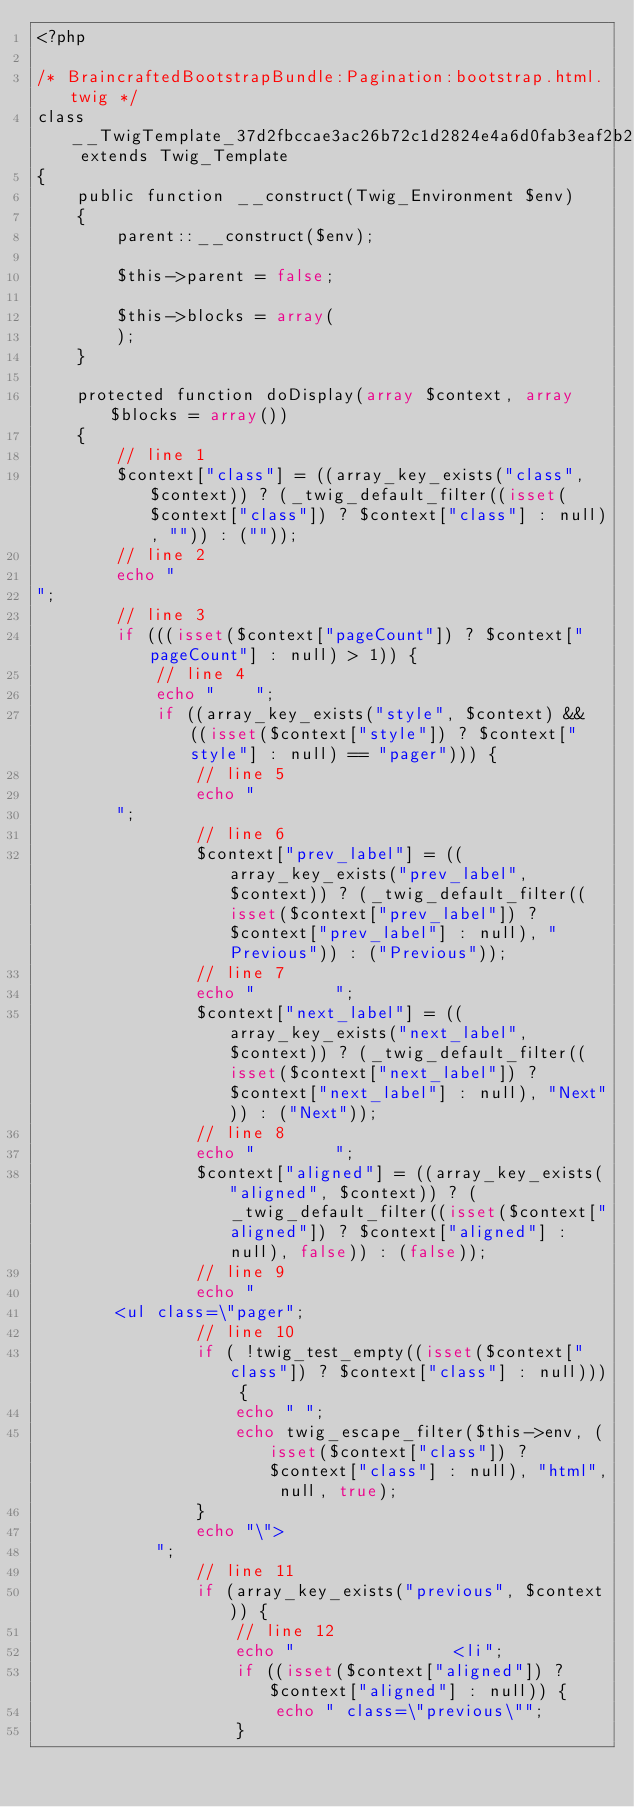<code> <loc_0><loc_0><loc_500><loc_500><_PHP_><?php

/* BraincraftedBootstrapBundle:Pagination:bootstrap.html.twig */
class __TwigTemplate_37d2fbccae3ac26b72c1d2824e4a6d0fab3eaf2b2bd7ce29ca5ebdf883d66af6 extends Twig_Template
{
    public function __construct(Twig_Environment $env)
    {
        parent::__construct($env);

        $this->parent = false;

        $this->blocks = array(
        );
    }

    protected function doDisplay(array $context, array $blocks = array())
    {
        // line 1
        $context["class"] = ((array_key_exists("class", $context)) ? (_twig_default_filter((isset($context["class"]) ? $context["class"] : null), "")) : (""));
        // line 2
        echo "
";
        // line 3
        if (((isset($context["pageCount"]) ? $context["pageCount"] : null) > 1)) {
            // line 4
            echo "    ";
            if ((array_key_exists("style", $context) && ((isset($context["style"]) ? $context["style"] : null) == "pager"))) {
                // line 5
                echo "
        ";
                // line 6
                $context["prev_label"] = ((array_key_exists("prev_label", $context)) ? (_twig_default_filter((isset($context["prev_label"]) ? $context["prev_label"] : null), "Previous")) : ("Previous"));
                // line 7
                echo "        ";
                $context["next_label"] = ((array_key_exists("next_label", $context)) ? (_twig_default_filter((isset($context["next_label"]) ? $context["next_label"] : null), "Next")) : ("Next"));
                // line 8
                echo "        ";
                $context["aligned"] = ((array_key_exists("aligned", $context)) ? (_twig_default_filter((isset($context["aligned"]) ? $context["aligned"] : null), false)) : (false));
                // line 9
                echo "
        <ul class=\"pager";
                // line 10
                if ( !twig_test_empty((isset($context["class"]) ? $context["class"] : null))) {
                    echo " ";
                    echo twig_escape_filter($this->env, (isset($context["class"]) ? $context["class"] : null), "html", null, true);
                }
                echo "\">
            ";
                // line 11
                if (array_key_exists("previous", $context)) {
                    // line 12
                    echo "                <li";
                    if ((isset($context["aligned"]) ? $context["aligned"] : null)) {
                        echo " class=\"previous\"";
                    }</code> 